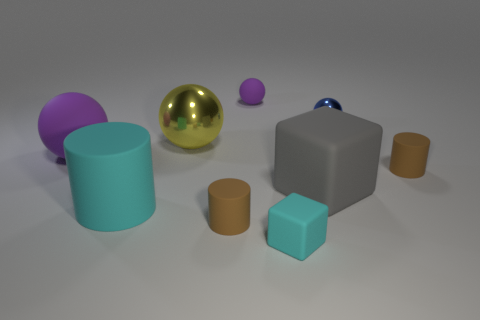The other metallic thing that is the same shape as the large yellow object is what size?
Offer a terse response. Small. The small brown object that is to the left of the small cylinder right of the blue object is made of what material?
Keep it short and to the point. Rubber. Is the shape of the small purple matte thing the same as the big yellow metal object?
Give a very brief answer. Yes. How many tiny objects are in front of the big purple sphere and behind the yellow ball?
Make the answer very short. 0. Is the number of tiny purple rubber things right of the big purple matte thing the same as the number of cyan matte blocks that are behind the big cyan rubber cylinder?
Keep it short and to the point. No. There is a thing right of the tiny metal ball; does it have the same size as the metal sphere that is to the left of the tiny blue ball?
Offer a very short reply. No. What is the object that is both in front of the blue thing and behind the large purple object made of?
Keep it short and to the point. Metal. Are there fewer large gray cubes than purple matte objects?
Ensure brevity in your answer.  Yes. There is a purple object on the left side of the purple thing that is to the right of the yellow sphere; what size is it?
Ensure brevity in your answer.  Large. The metallic object on the right side of the large ball that is behind the big ball on the left side of the large yellow thing is what shape?
Your response must be concise. Sphere. 